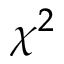<formula> <loc_0><loc_0><loc_500><loc_500>\chi ^ { 2 }</formula> 